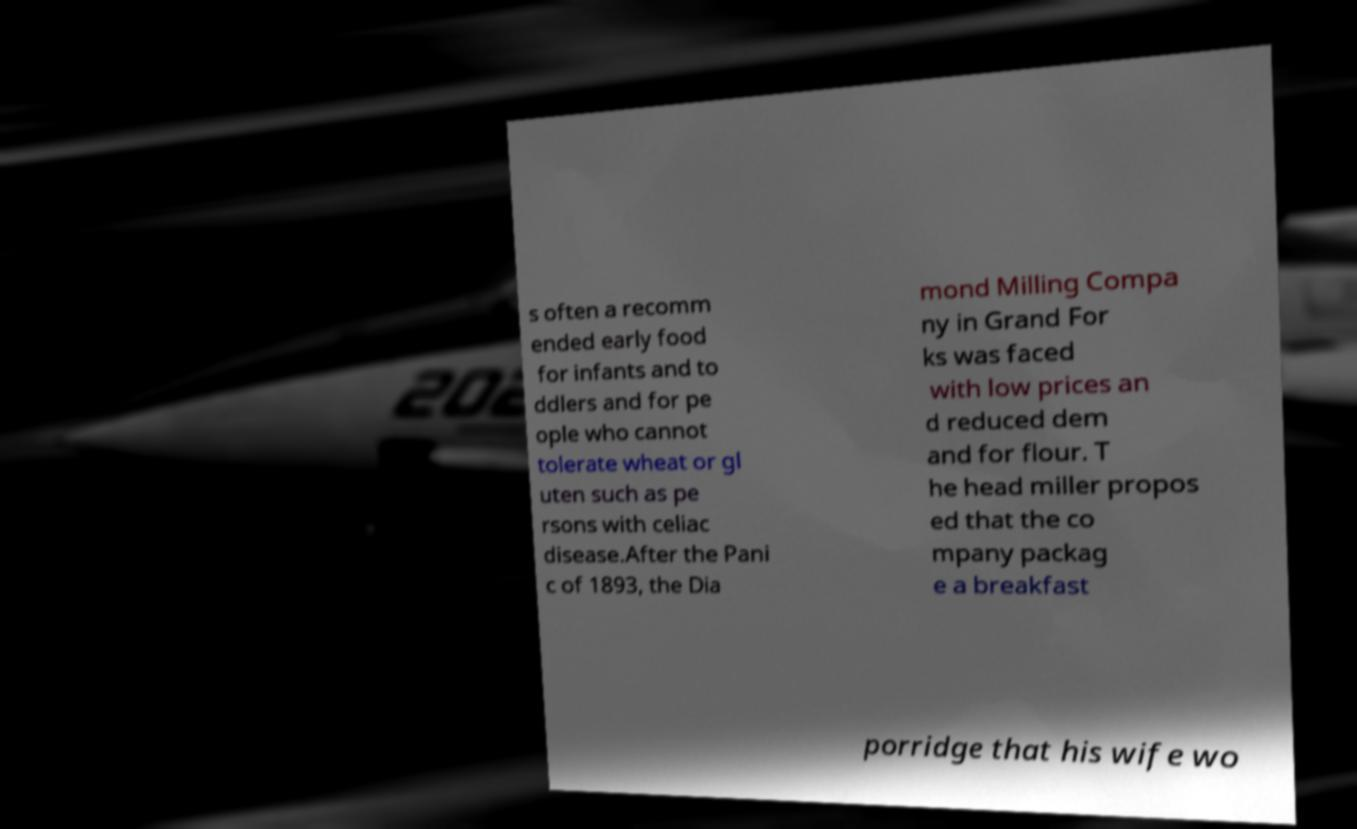Can you accurately transcribe the text from the provided image for me? s often a recomm ended early food for infants and to ddlers and for pe ople who cannot tolerate wheat or gl uten such as pe rsons with celiac disease.After the Pani c of 1893, the Dia mond Milling Compa ny in Grand For ks was faced with low prices an d reduced dem and for flour. T he head miller propos ed that the co mpany packag e a breakfast porridge that his wife wo 